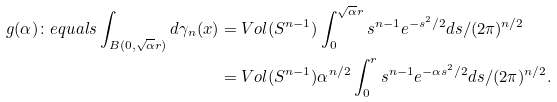<formula> <loc_0><loc_0><loc_500><loc_500>g ( \alpha ) \colon e q u a l s \int _ { B ( 0 , \sqrt { \alpha } r ) } d \gamma _ { n } ( x ) & = V o l ( S ^ { n - 1 } ) \int _ { 0 } ^ { \sqrt { \alpha } r } s ^ { n - 1 } e ^ { - s ^ { 2 } / 2 } d s / ( 2 \pi ) ^ { n / 2 } \\ & = V o l ( S ^ { n - 1 } ) \alpha ^ { n / 2 } \int _ { 0 } ^ { r } s ^ { n - 1 } e ^ { - \alpha s ^ { 2 } / 2 } d s / ( 2 \pi ) ^ { n / 2 } .</formula> 